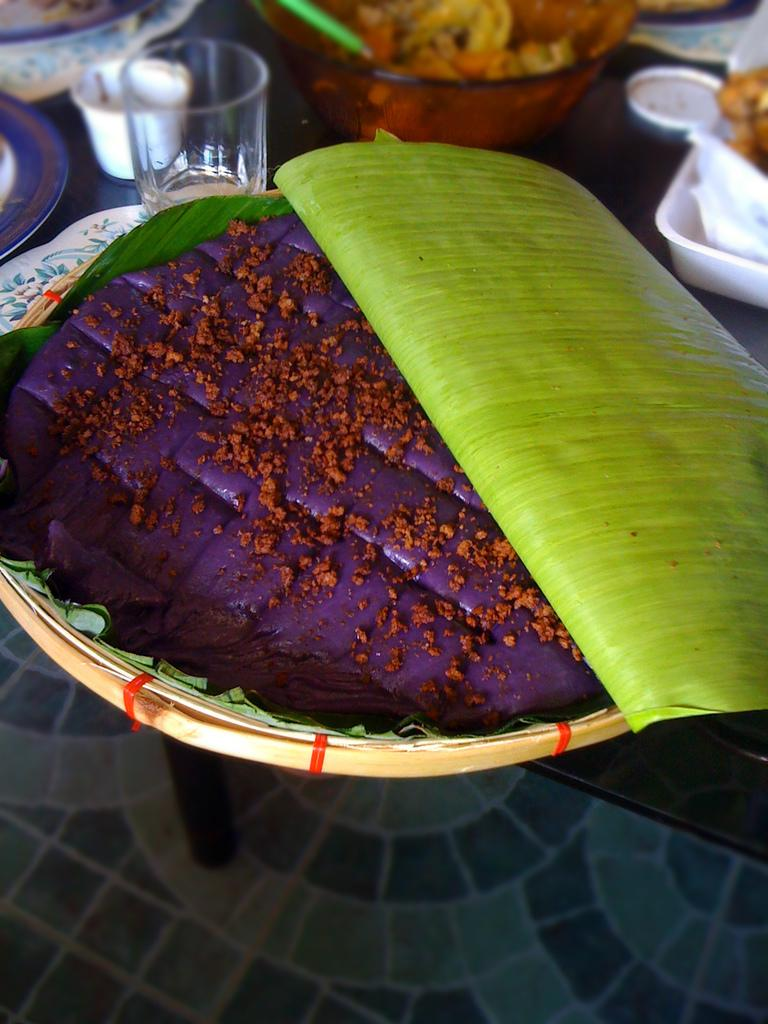What type of furniture is present in the image? There is a table in the image. What objects are placed on the table? There is a glass, a cup, plates, a box, a bowl with a food item, a basket with a food item, and a banana leaf on the table. What can be used for drinking in the image? There is a glass and a cup on the table. What can be used for serving food in the image? There are plates, a bowl, and a basket with a food item on the table. What type of instrument is being played on the table in the image? There is no instrument present on the table in the image. What is the table made of in the image? The provided facts do not mention the material of the table, so we cannot determine its composition from the image. 